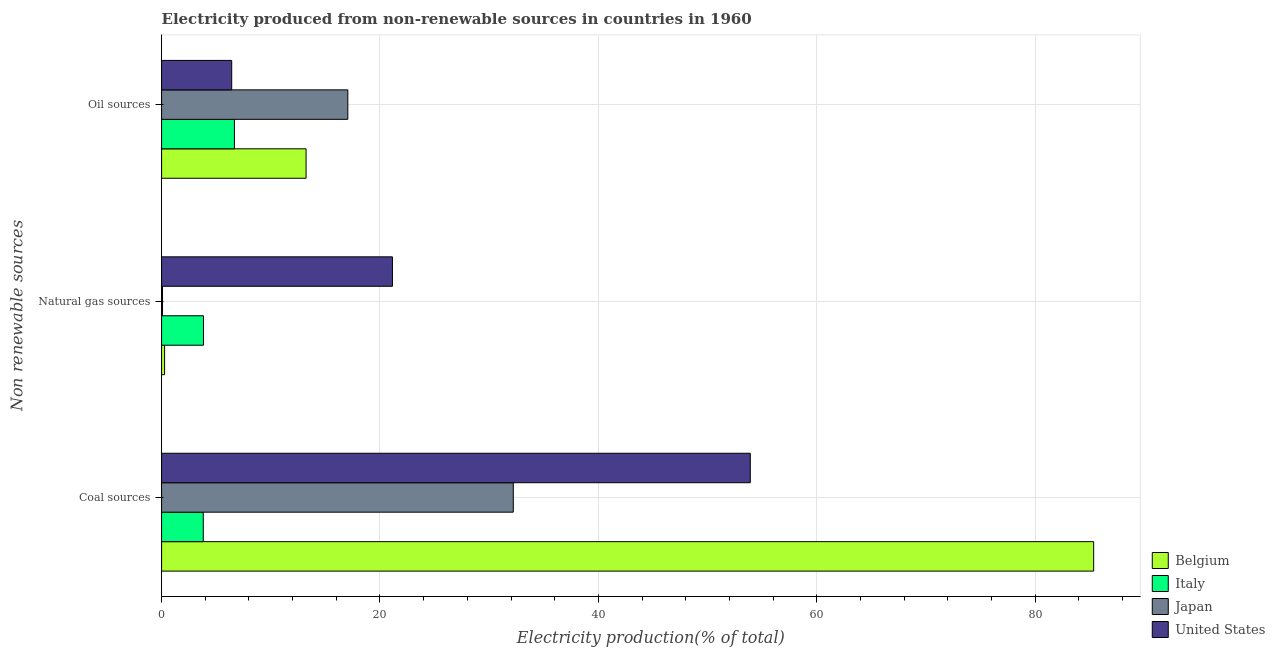How many different coloured bars are there?
Your response must be concise. 4. Are the number of bars per tick equal to the number of legend labels?
Keep it short and to the point. Yes. Are the number of bars on each tick of the Y-axis equal?
Keep it short and to the point. Yes. How many bars are there on the 3rd tick from the bottom?
Give a very brief answer. 4. What is the label of the 3rd group of bars from the top?
Offer a terse response. Coal sources. What is the percentage of electricity produced by natural gas in Italy?
Offer a terse response. 3.84. Across all countries, what is the maximum percentage of electricity produced by oil sources?
Give a very brief answer. 17.06. Across all countries, what is the minimum percentage of electricity produced by coal?
Offer a terse response. 3.82. What is the total percentage of electricity produced by natural gas in the graph?
Provide a short and direct response. 25.34. What is the difference between the percentage of electricity produced by coal in United States and that in Italy?
Your response must be concise. 50.09. What is the difference between the percentage of electricity produced by natural gas in Belgium and the percentage of electricity produced by coal in United States?
Your response must be concise. -53.63. What is the average percentage of electricity produced by coal per country?
Make the answer very short. 43.82. What is the difference between the percentage of electricity produced by natural gas and percentage of electricity produced by coal in Belgium?
Keep it short and to the point. -85.08. In how many countries, is the percentage of electricity produced by coal greater than 60 %?
Your response must be concise. 1. What is the ratio of the percentage of electricity produced by oil sources in Belgium to that in Japan?
Offer a terse response. 0.78. What is the difference between the highest and the second highest percentage of electricity produced by coal?
Offer a terse response. 31.44. What is the difference between the highest and the lowest percentage of electricity produced by coal?
Give a very brief answer. 81.54. Is the sum of the percentage of electricity produced by coal in United States and Japan greater than the maximum percentage of electricity produced by oil sources across all countries?
Your answer should be compact. Yes. Is it the case that in every country, the sum of the percentage of electricity produced by coal and percentage of electricity produced by natural gas is greater than the percentage of electricity produced by oil sources?
Provide a short and direct response. Yes. How many bars are there?
Give a very brief answer. 12. What is the difference between two consecutive major ticks on the X-axis?
Provide a short and direct response. 20. Are the values on the major ticks of X-axis written in scientific E-notation?
Give a very brief answer. No. Does the graph contain any zero values?
Keep it short and to the point. No. Does the graph contain grids?
Make the answer very short. Yes. How are the legend labels stacked?
Provide a succinct answer. Vertical. What is the title of the graph?
Provide a short and direct response. Electricity produced from non-renewable sources in countries in 1960. What is the label or title of the Y-axis?
Your answer should be very brief. Non renewable sources. What is the Electricity production(% of total) of Belgium in Coal sources?
Make the answer very short. 85.36. What is the Electricity production(% of total) of Italy in Coal sources?
Offer a terse response. 3.82. What is the Electricity production(% of total) of Japan in Coal sources?
Keep it short and to the point. 32.21. What is the Electricity production(% of total) in United States in Coal sources?
Provide a succinct answer. 53.91. What is the Electricity production(% of total) of Belgium in Natural gas sources?
Provide a short and direct response. 0.28. What is the Electricity production(% of total) in Italy in Natural gas sources?
Your answer should be very brief. 3.84. What is the Electricity production(% of total) of Japan in Natural gas sources?
Provide a short and direct response. 0.09. What is the Electricity production(% of total) in United States in Natural gas sources?
Keep it short and to the point. 21.14. What is the Electricity production(% of total) of Belgium in Oil sources?
Ensure brevity in your answer.  13.23. What is the Electricity production(% of total) of Italy in Oil sources?
Keep it short and to the point. 6.67. What is the Electricity production(% of total) in Japan in Oil sources?
Provide a short and direct response. 17.06. What is the Electricity production(% of total) of United States in Oil sources?
Offer a very short reply. 6.42. Across all Non renewable sources, what is the maximum Electricity production(% of total) in Belgium?
Keep it short and to the point. 85.36. Across all Non renewable sources, what is the maximum Electricity production(% of total) of Italy?
Offer a terse response. 6.67. Across all Non renewable sources, what is the maximum Electricity production(% of total) in Japan?
Provide a succinct answer. 32.21. Across all Non renewable sources, what is the maximum Electricity production(% of total) of United States?
Provide a succinct answer. 53.91. Across all Non renewable sources, what is the minimum Electricity production(% of total) of Belgium?
Your response must be concise. 0.28. Across all Non renewable sources, what is the minimum Electricity production(% of total) in Italy?
Make the answer very short. 3.82. Across all Non renewable sources, what is the minimum Electricity production(% of total) in Japan?
Keep it short and to the point. 0.09. Across all Non renewable sources, what is the minimum Electricity production(% of total) in United States?
Give a very brief answer. 6.42. What is the total Electricity production(% of total) in Belgium in the graph?
Provide a succinct answer. 98.86. What is the total Electricity production(% of total) of Italy in the graph?
Provide a short and direct response. 14.33. What is the total Electricity production(% of total) of Japan in the graph?
Give a very brief answer. 49.35. What is the total Electricity production(% of total) of United States in the graph?
Provide a short and direct response. 81.48. What is the difference between the Electricity production(% of total) of Belgium in Coal sources and that in Natural gas sources?
Provide a short and direct response. 85.08. What is the difference between the Electricity production(% of total) of Italy in Coal sources and that in Natural gas sources?
Provide a succinct answer. -0.02. What is the difference between the Electricity production(% of total) of Japan in Coal sources and that in Natural gas sources?
Offer a very short reply. 32.12. What is the difference between the Electricity production(% of total) in United States in Coal sources and that in Natural gas sources?
Provide a short and direct response. 32.77. What is the difference between the Electricity production(% of total) of Belgium in Coal sources and that in Oil sources?
Provide a short and direct response. 72.12. What is the difference between the Electricity production(% of total) of Italy in Coal sources and that in Oil sources?
Your answer should be very brief. -2.85. What is the difference between the Electricity production(% of total) of Japan in Coal sources and that in Oil sources?
Give a very brief answer. 15.15. What is the difference between the Electricity production(% of total) in United States in Coal sources and that in Oil sources?
Offer a terse response. 47.49. What is the difference between the Electricity production(% of total) in Belgium in Natural gas sources and that in Oil sources?
Offer a very short reply. -12.96. What is the difference between the Electricity production(% of total) in Italy in Natural gas sources and that in Oil sources?
Provide a short and direct response. -2.83. What is the difference between the Electricity production(% of total) in Japan in Natural gas sources and that in Oil sources?
Give a very brief answer. -16.97. What is the difference between the Electricity production(% of total) of United States in Natural gas sources and that in Oil sources?
Give a very brief answer. 14.72. What is the difference between the Electricity production(% of total) of Belgium in Coal sources and the Electricity production(% of total) of Italy in Natural gas sources?
Your answer should be very brief. 81.52. What is the difference between the Electricity production(% of total) in Belgium in Coal sources and the Electricity production(% of total) in Japan in Natural gas sources?
Offer a terse response. 85.27. What is the difference between the Electricity production(% of total) in Belgium in Coal sources and the Electricity production(% of total) in United States in Natural gas sources?
Give a very brief answer. 64.21. What is the difference between the Electricity production(% of total) in Italy in Coal sources and the Electricity production(% of total) in Japan in Natural gas sources?
Your answer should be very brief. 3.73. What is the difference between the Electricity production(% of total) in Italy in Coal sources and the Electricity production(% of total) in United States in Natural gas sources?
Your response must be concise. -17.32. What is the difference between the Electricity production(% of total) of Japan in Coal sources and the Electricity production(% of total) of United States in Natural gas sources?
Give a very brief answer. 11.07. What is the difference between the Electricity production(% of total) in Belgium in Coal sources and the Electricity production(% of total) in Italy in Oil sources?
Provide a short and direct response. 78.68. What is the difference between the Electricity production(% of total) in Belgium in Coal sources and the Electricity production(% of total) in Japan in Oil sources?
Your answer should be very brief. 68.3. What is the difference between the Electricity production(% of total) in Belgium in Coal sources and the Electricity production(% of total) in United States in Oil sources?
Offer a very short reply. 78.93. What is the difference between the Electricity production(% of total) of Italy in Coal sources and the Electricity production(% of total) of Japan in Oil sources?
Provide a succinct answer. -13.24. What is the difference between the Electricity production(% of total) of Italy in Coal sources and the Electricity production(% of total) of United States in Oil sources?
Your answer should be compact. -2.6. What is the difference between the Electricity production(% of total) in Japan in Coal sources and the Electricity production(% of total) in United States in Oil sources?
Your answer should be compact. 25.79. What is the difference between the Electricity production(% of total) of Belgium in Natural gas sources and the Electricity production(% of total) of Italy in Oil sources?
Your answer should be compact. -6.39. What is the difference between the Electricity production(% of total) in Belgium in Natural gas sources and the Electricity production(% of total) in Japan in Oil sources?
Ensure brevity in your answer.  -16.78. What is the difference between the Electricity production(% of total) of Belgium in Natural gas sources and the Electricity production(% of total) of United States in Oil sources?
Your answer should be very brief. -6.15. What is the difference between the Electricity production(% of total) in Italy in Natural gas sources and the Electricity production(% of total) in Japan in Oil sources?
Give a very brief answer. -13.22. What is the difference between the Electricity production(% of total) of Italy in Natural gas sources and the Electricity production(% of total) of United States in Oil sources?
Ensure brevity in your answer.  -2.58. What is the difference between the Electricity production(% of total) in Japan in Natural gas sources and the Electricity production(% of total) in United States in Oil sources?
Make the answer very short. -6.34. What is the average Electricity production(% of total) of Belgium per Non renewable sources?
Offer a very short reply. 32.95. What is the average Electricity production(% of total) of Italy per Non renewable sources?
Your answer should be compact. 4.78. What is the average Electricity production(% of total) in Japan per Non renewable sources?
Make the answer very short. 16.45. What is the average Electricity production(% of total) in United States per Non renewable sources?
Provide a short and direct response. 27.16. What is the difference between the Electricity production(% of total) in Belgium and Electricity production(% of total) in Italy in Coal sources?
Ensure brevity in your answer.  81.54. What is the difference between the Electricity production(% of total) in Belgium and Electricity production(% of total) in Japan in Coal sources?
Provide a short and direct response. 53.15. What is the difference between the Electricity production(% of total) in Belgium and Electricity production(% of total) in United States in Coal sources?
Your response must be concise. 31.44. What is the difference between the Electricity production(% of total) of Italy and Electricity production(% of total) of Japan in Coal sources?
Make the answer very short. -28.39. What is the difference between the Electricity production(% of total) of Italy and Electricity production(% of total) of United States in Coal sources?
Make the answer very short. -50.09. What is the difference between the Electricity production(% of total) in Japan and Electricity production(% of total) in United States in Coal sources?
Offer a very short reply. -21.7. What is the difference between the Electricity production(% of total) in Belgium and Electricity production(% of total) in Italy in Natural gas sources?
Provide a succinct answer. -3.56. What is the difference between the Electricity production(% of total) of Belgium and Electricity production(% of total) of Japan in Natural gas sources?
Keep it short and to the point. 0.19. What is the difference between the Electricity production(% of total) in Belgium and Electricity production(% of total) in United States in Natural gas sources?
Make the answer very short. -20.86. What is the difference between the Electricity production(% of total) in Italy and Electricity production(% of total) in Japan in Natural gas sources?
Make the answer very short. 3.75. What is the difference between the Electricity production(% of total) of Italy and Electricity production(% of total) of United States in Natural gas sources?
Make the answer very short. -17.3. What is the difference between the Electricity production(% of total) of Japan and Electricity production(% of total) of United States in Natural gas sources?
Your answer should be compact. -21.05. What is the difference between the Electricity production(% of total) of Belgium and Electricity production(% of total) of Italy in Oil sources?
Your answer should be compact. 6.56. What is the difference between the Electricity production(% of total) in Belgium and Electricity production(% of total) in Japan in Oil sources?
Your answer should be very brief. -3.82. What is the difference between the Electricity production(% of total) in Belgium and Electricity production(% of total) in United States in Oil sources?
Offer a terse response. 6.81. What is the difference between the Electricity production(% of total) of Italy and Electricity production(% of total) of Japan in Oil sources?
Your answer should be very brief. -10.39. What is the difference between the Electricity production(% of total) of Italy and Electricity production(% of total) of United States in Oil sources?
Provide a succinct answer. 0.25. What is the difference between the Electricity production(% of total) of Japan and Electricity production(% of total) of United States in Oil sources?
Provide a short and direct response. 10.63. What is the ratio of the Electricity production(% of total) in Belgium in Coal sources to that in Natural gas sources?
Provide a succinct answer. 307.93. What is the ratio of the Electricity production(% of total) in Italy in Coal sources to that in Natural gas sources?
Ensure brevity in your answer.  0.99. What is the ratio of the Electricity production(% of total) of Japan in Coal sources to that in Natural gas sources?
Provide a short and direct response. 372. What is the ratio of the Electricity production(% of total) of United States in Coal sources to that in Natural gas sources?
Make the answer very short. 2.55. What is the ratio of the Electricity production(% of total) of Belgium in Coal sources to that in Oil sources?
Your answer should be compact. 6.45. What is the ratio of the Electricity production(% of total) in Italy in Coal sources to that in Oil sources?
Your response must be concise. 0.57. What is the ratio of the Electricity production(% of total) in Japan in Coal sources to that in Oil sources?
Give a very brief answer. 1.89. What is the ratio of the Electricity production(% of total) of United States in Coal sources to that in Oil sources?
Ensure brevity in your answer.  8.39. What is the ratio of the Electricity production(% of total) of Belgium in Natural gas sources to that in Oil sources?
Provide a succinct answer. 0.02. What is the ratio of the Electricity production(% of total) of Italy in Natural gas sources to that in Oil sources?
Provide a succinct answer. 0.58. What is the ratio of the Electricity production(% of total) of Japan in Natural gas sources to that in Oil sources?
Your response must be concise. 0.01. What is the ratio of the Electricity production(% of total) in United States in Natural gas sources to that in Oil sources?
Give a very brief answer. 3.29. What is the difference between the highest and the second highest Electricity production(% of total) in Belgium?
Keep it short and to the point. 72.12. What is the difference between the highest and the second highest Electricity production(% of total) of Italy?
Provide a succinct answer. 2.83. What is the difference between the highest and the second highest Electricity production(% of total) of Japan?
Your response must be concise. 15.15. What is the difference between the highest and the second highest Electricity production(% of total) in United States?
Keep it short and to the point. 32.77. What is the difference between the highest and the lowest Electricity production(% of total) in Belgium?
Ensure brevity in your answer.  85.08. What is the difference between the highest and the lowest Electricity production(% of total) in Italy?
Provide a succinct answer. 2.85. What is the difference between the highest and the lowest Electricity production(% of total) of Japan?
Your answer should be very brief. 32.12. What is the difference between the highest and the lowest Electricity production(% of total) in United States?
Your response must be concise. 47.49. 